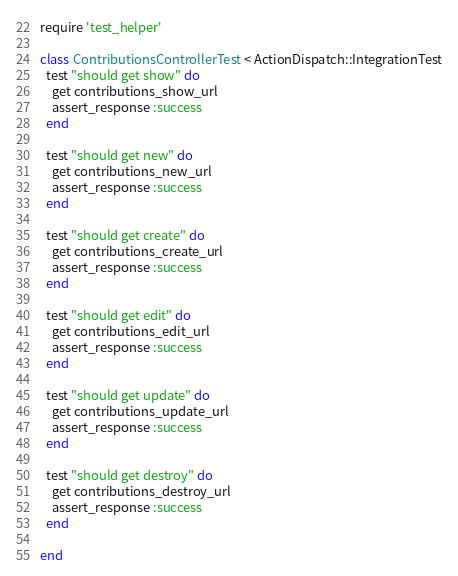Convert code to text. <code><loc_0><loc_0><loc_500><loc_500><_Ruby_>require 'test_helper'

class ContributionsControllerTest < ActionDispatch::IntegrationTest
  test "should get show" do
    get contributions_show_url
    assert_response :success
  end

  test "should get new" do
    get contributions_new_url
    assert_response :success
  end

  test "should get create" do
    get contributions_create_url
    assert_response :success
  end

  test "should get edit" do
    get contributions_edit_url
    assert_response :success
  end

  test "should get update" do
    get contributions_update_url
    assert_response :success
  end

  test "should get destroy" do
    get contributions_destroy_url
    assert_response :success
  end

end
</code> 